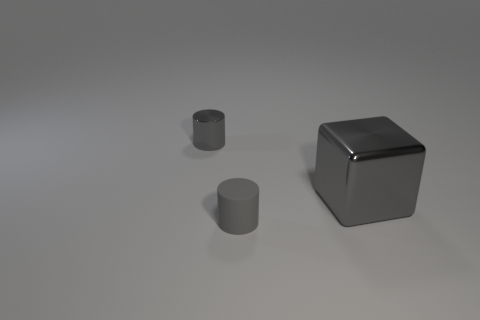Is there anything else that has the same size as the metal cube?
Offer a very short reply. No. What material is the cylinder that is the same color as the small shiny thing?
Keep it short and to the point. Rubber. There is a metal object that is to the right of the tiny gray metal cylinder; does it have the same color as the small metallic thing?
Your response must be concise. Yes. What number of other things are there of the same color as the matte cylinder?
Provide a succinct answer. 2. What material is the block?
Your response must be concise. Metal. How many other things are made of the same material as the gray cube?
Provide a short and direct response. 1. How big is the gray thing that is behind the small rubber cylinder and left of the big gray thing?
Your answer should be very brief. Small. What is the shape of the thing behind the gray metal object that is on the right side of the small gray metal thing?
Offer a terse response. Cylinder. Is there anything else that is the same shape as the small rubber object?
Give a very brief answer. Yes. Are there an equal number of small gray metal things right of the tiny rubber cylinder and tiny red matte cylinders?
Your answer should be very brief. Yes. 